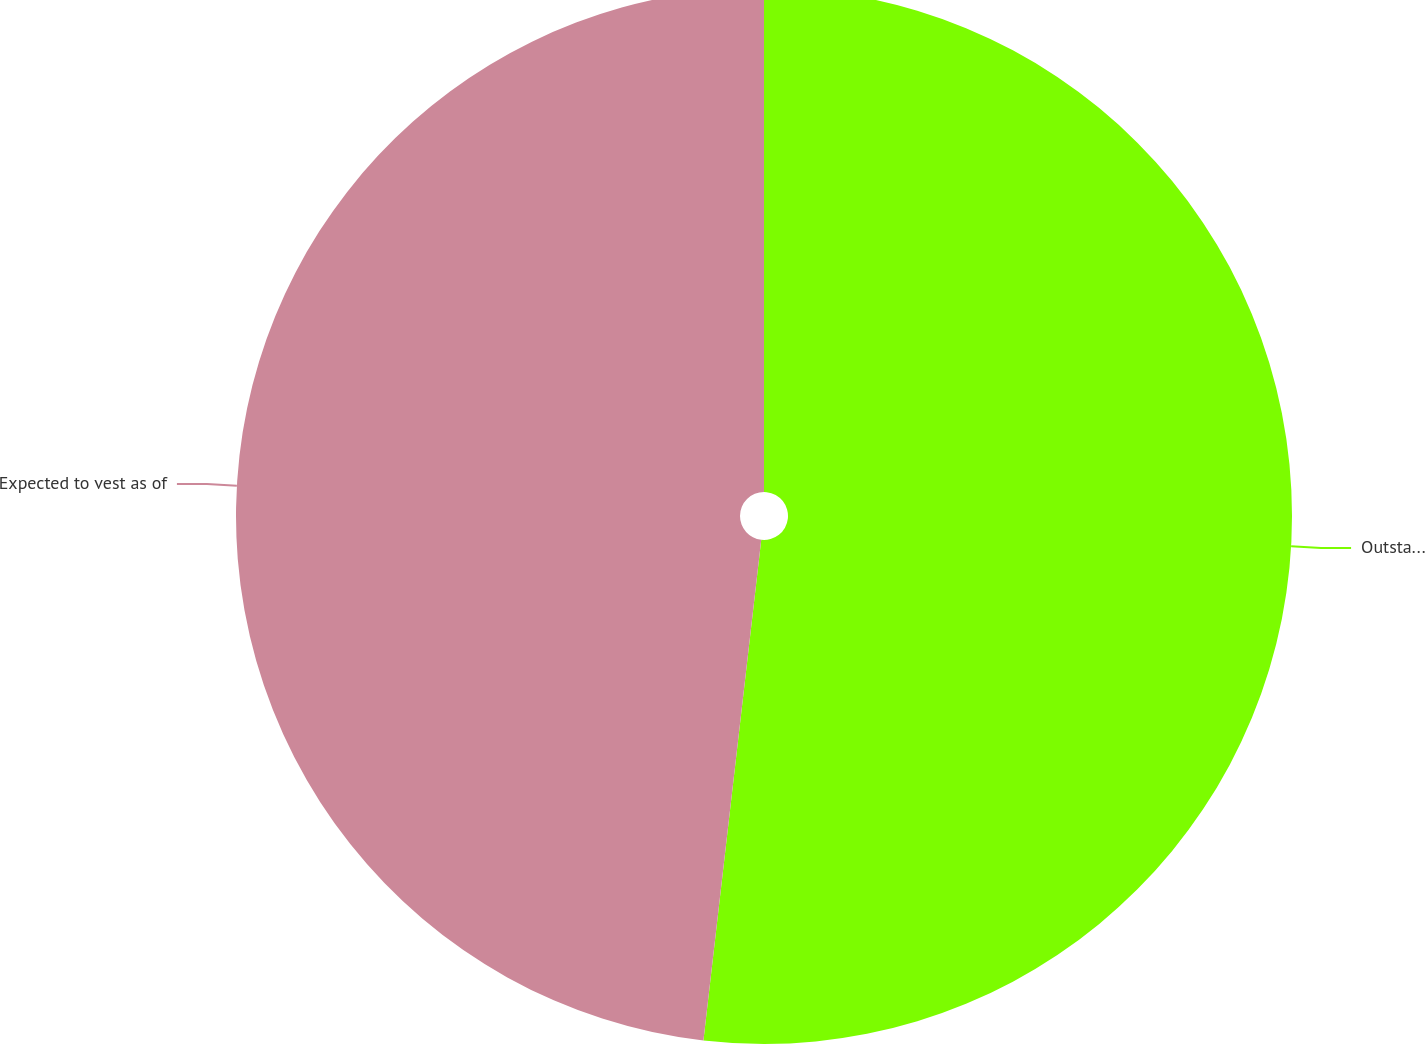Convert chart to OTSL. <chart><loc_0><loc_0><loc_500><loc_500><pie_chart><fcel>Outstanding at December 26<fcel>Expected to vest as of<nl><fcel>51.83%<fcel>48.17%<nl></chart> 